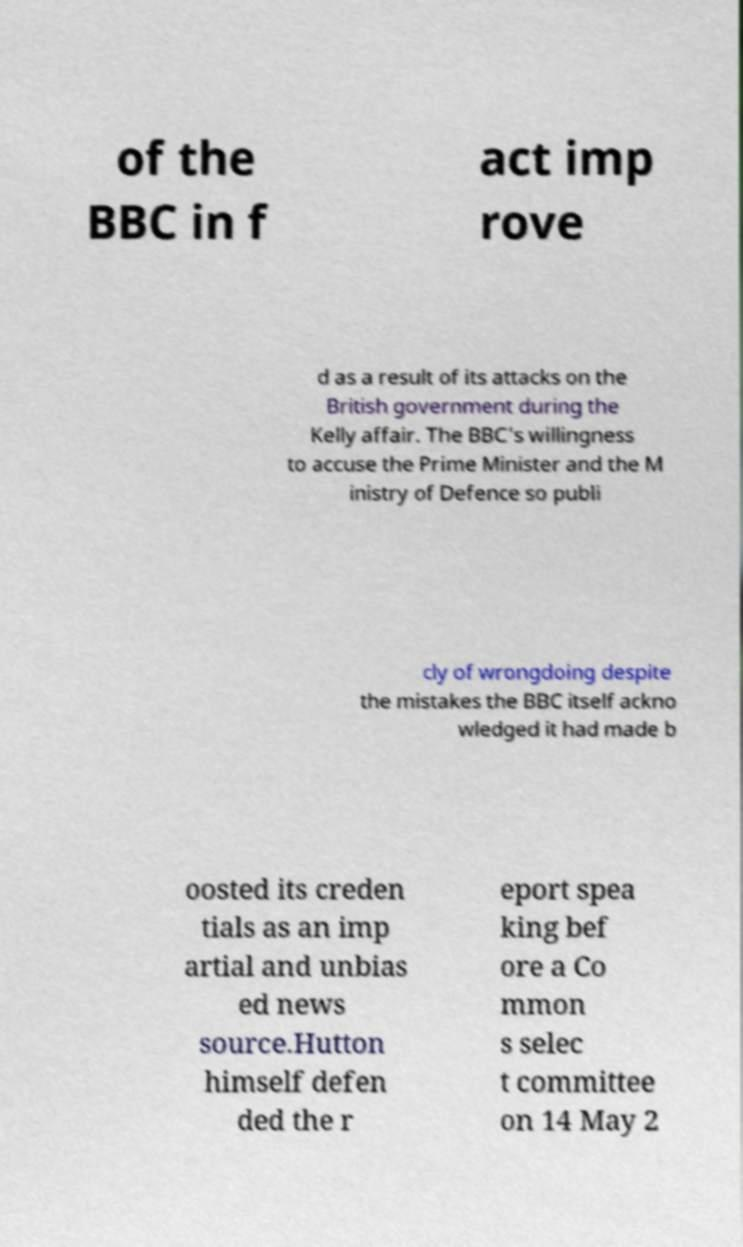There's text embedded in this image that I need extracted. Can you transcribe it verbatim? of the BBC in f act imp rove d as a result of its attacks on the British government during the Kelly affair. The BBC's willingness to accuse the Prime Minister and the M inistry of Defence so publi cly of wrongdoing despite the mistakes the BBC itself ackno wledged it had made b oosted its creden tials as an imp artial and unbias ed news source.Hutton himself defen ded the r eport spea king bef ore a Co mmon s selec t committee on 14 May 2 